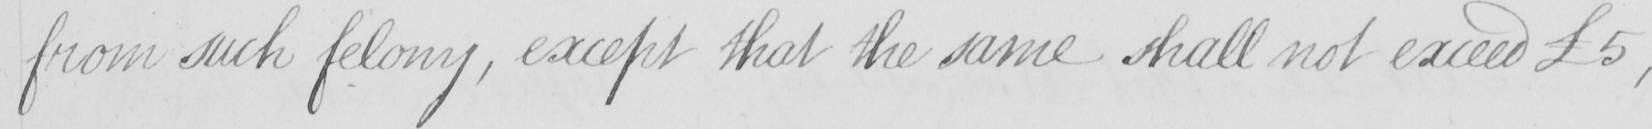Transcribe the text shown in this historical manuscript line. from such felony , except that the same shall not exceed  £5 , 